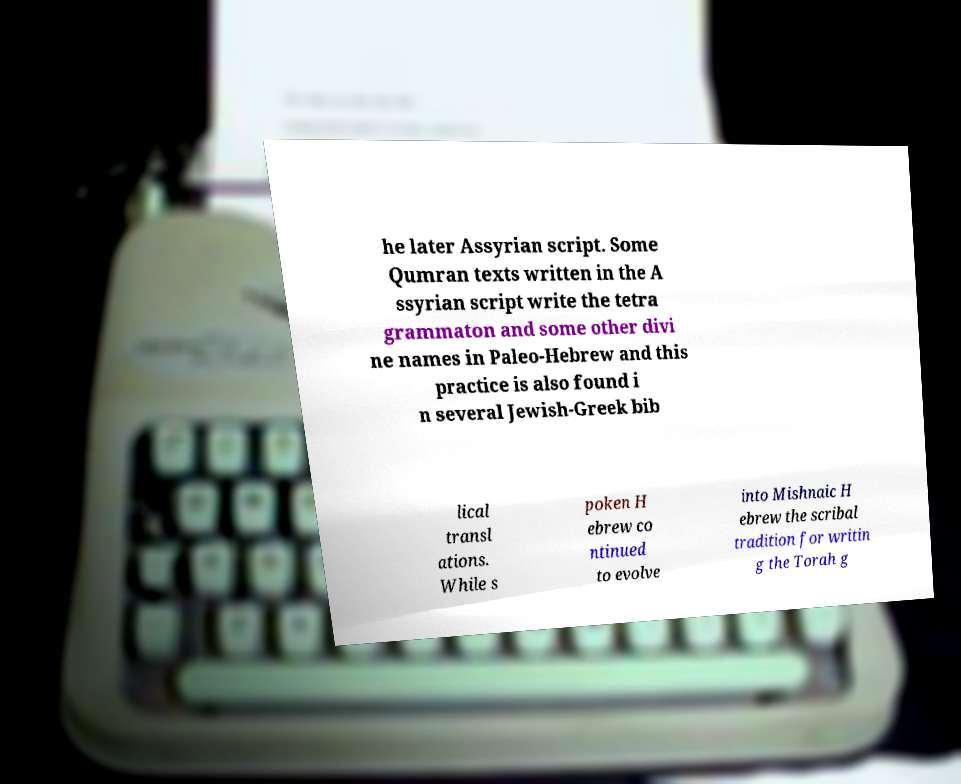Can you read and provide the text displayed in the image?This photo seems to have some interesting text. Can you extract and type it out for me? he later Assyrian script. Some Qumran texts written in the A ssyrian script write the tetra grammaton and some other divi ne names in Paleo-Hebrew and this practice is also found i n several Jewish-Greek bib lical transl ations. While s poken H ebrew co ntinued to evolve into Mishnaic H ebrew the scribal tradition for writin g the Torah g 